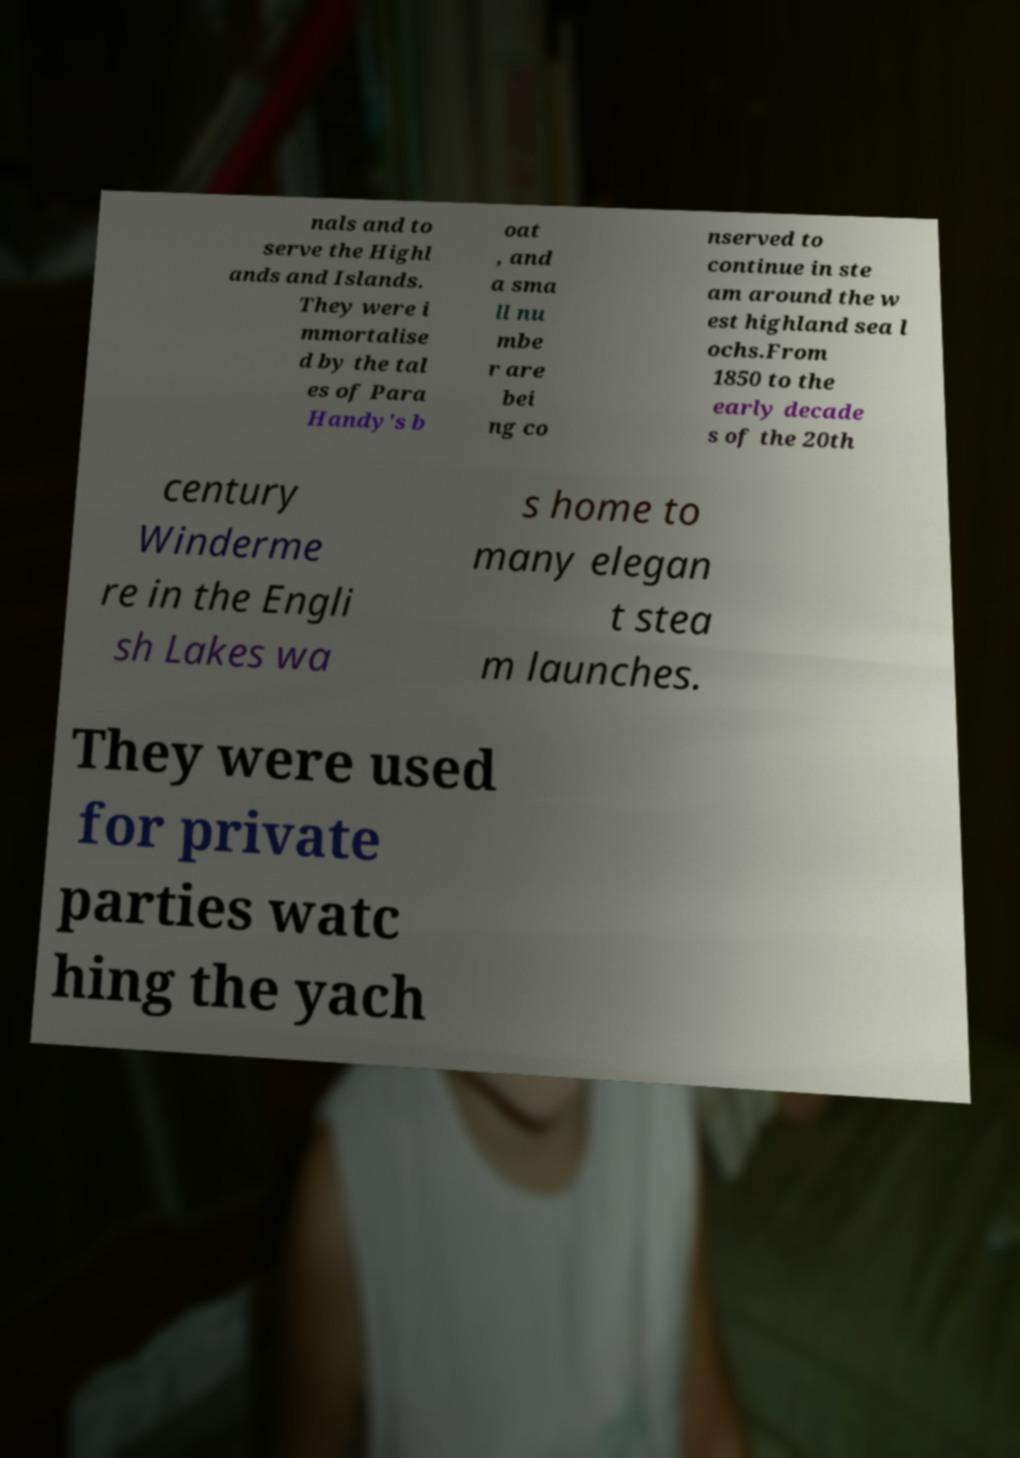For documentation purposes, I need the text within this image transcribed. Could you provide that? nals and to serve the Highl ands and Islands. They were i mmortalise d by the tal es of Para Handy's b oat , and a sma ll nu mbe r are bei ng co nserved to continue in ste am around the w est highland sea l ochs.From 1850 to the early decade s of the 20th century Winderme re in the Engli sh Lakes wa s home to many elegan t stea m launches. They were used for private parties watc hing the yach 